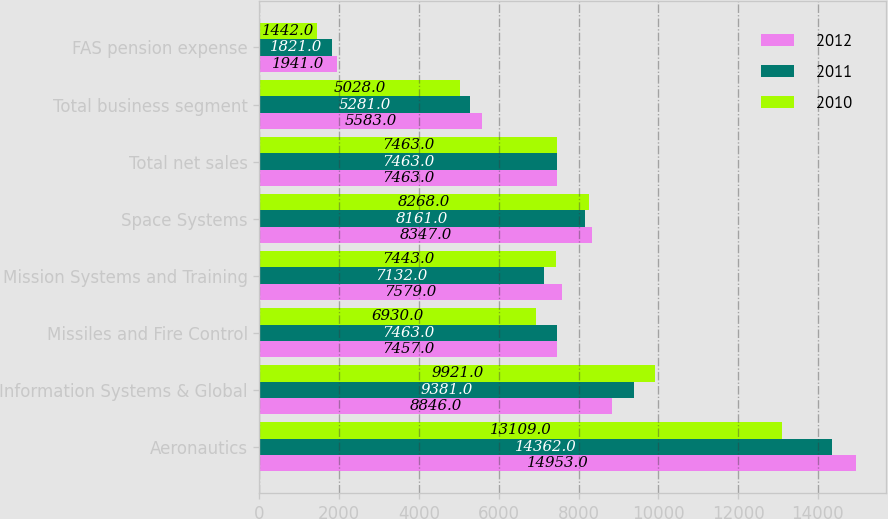<chart> <loc_0><loc_0><loc_500><loc_500><stacked_bar_chart><ecel><fcel>Aeronautics<fcel>Information Systems & Global<fcel>Missiles and Fire Control<fcel>Mission Systems and Training<fcel>Space Systems<fcel>Total net sales<fcel>Total business segment<fcel>FAS pension expense<nl><fcel>2012<fcel>14953<fcel>8846<fcel>7457<fcel>7579<fcel>8347<fcel>7463<fcel>5583<fcel>1941<nl><fcel>2011<fcel>14362<fcel>9381<fcel>7463<fcel>7132<fcel>8161<fcel>7463<fcel>5281<fcel>1821<nl><fcel>2010<fcel>13109<fcel>9921<fcel>6930<fcel>7443<fcel>8268<fcel>7463<fcel>5028<fcel>1442<nl></chart> 